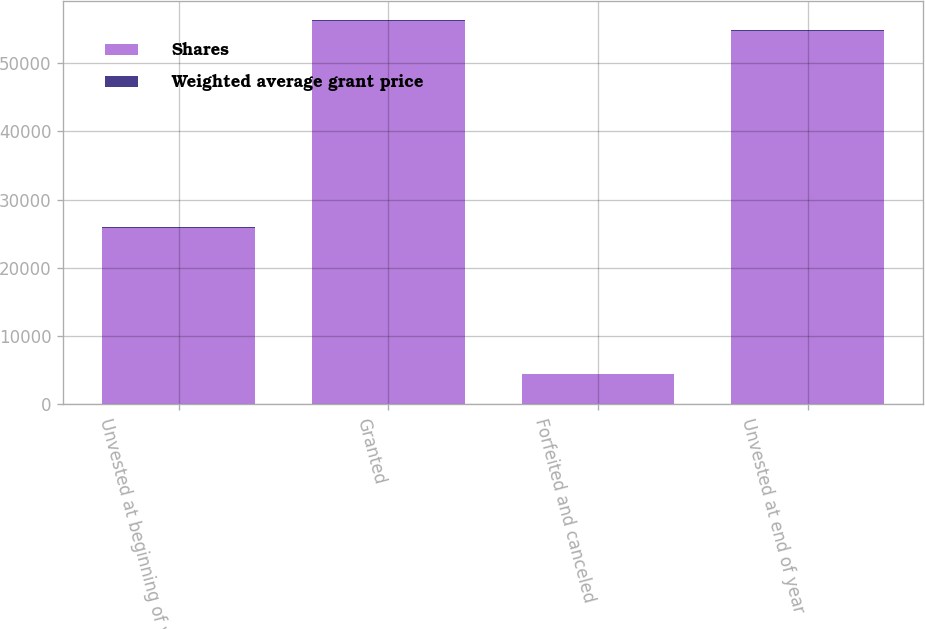Convert chart. <chart><loc_0><loc_0><loc_500><loc_500><stacked_bar_chart><ecel><fcel>Unvested at beginning of year<fcel>Granted<fcel>Forfeited and canceled<fcel>Unvested at end of year<nl><fcel>Shares<fcel>25820<fcel>56177<fcel>4382<fcel>54676<nl><fcel>Weighted average grant price<fcel>168.22<fcel>155.21<fcel>122.06<fcel>147.1<nl></chart> 